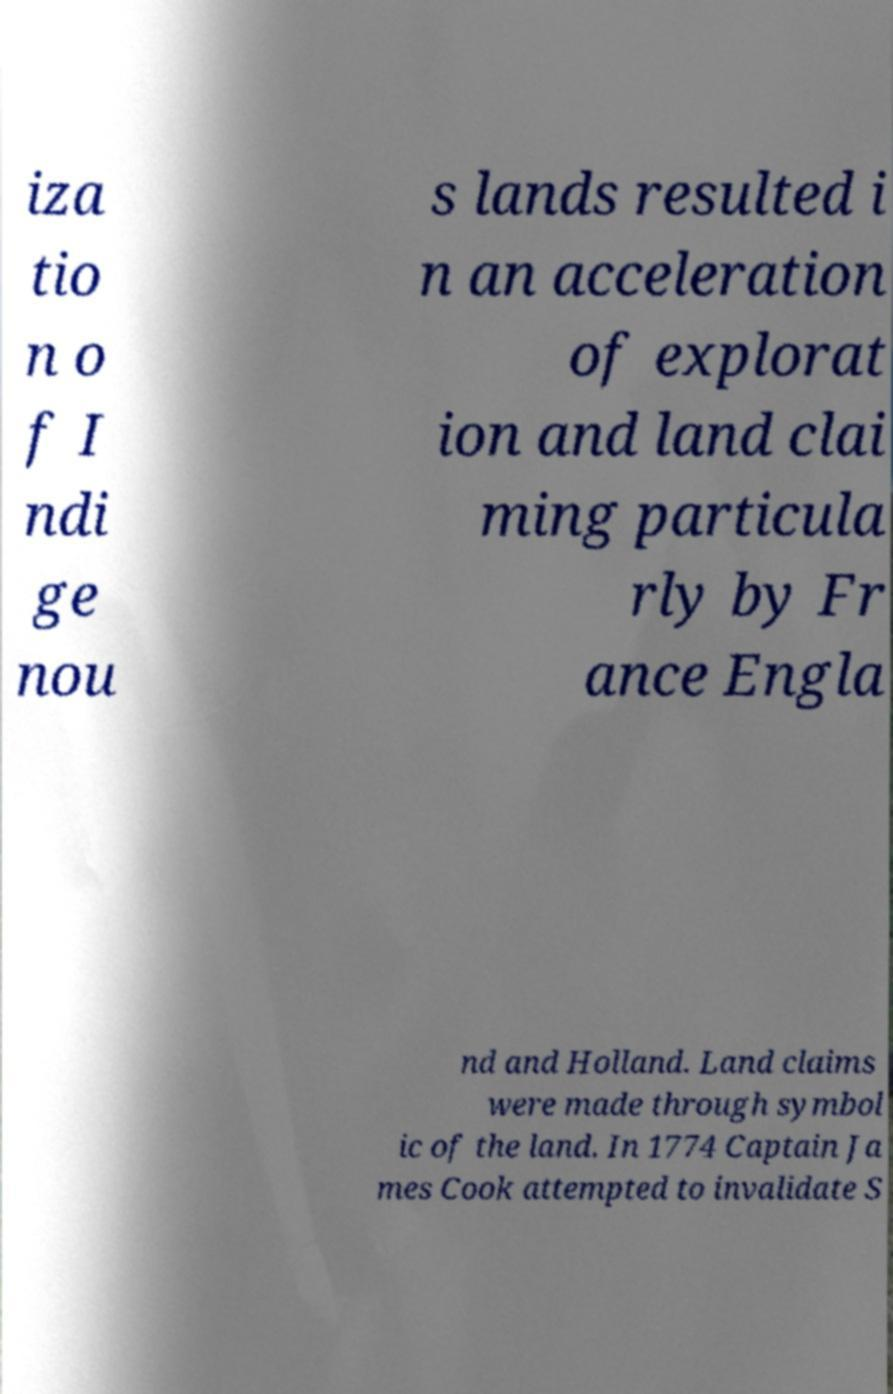Could you extract and type out the text from this image? iza tio n o f I ndi ge nou s lands resulted i n an acceleration of explorat ion and land clai ming particula rly by Fr ance Engla nd and Holland. Land claims were made through symbol ic of the land. In 1774 Captain Ja mes Cook attempted to invalidate S 